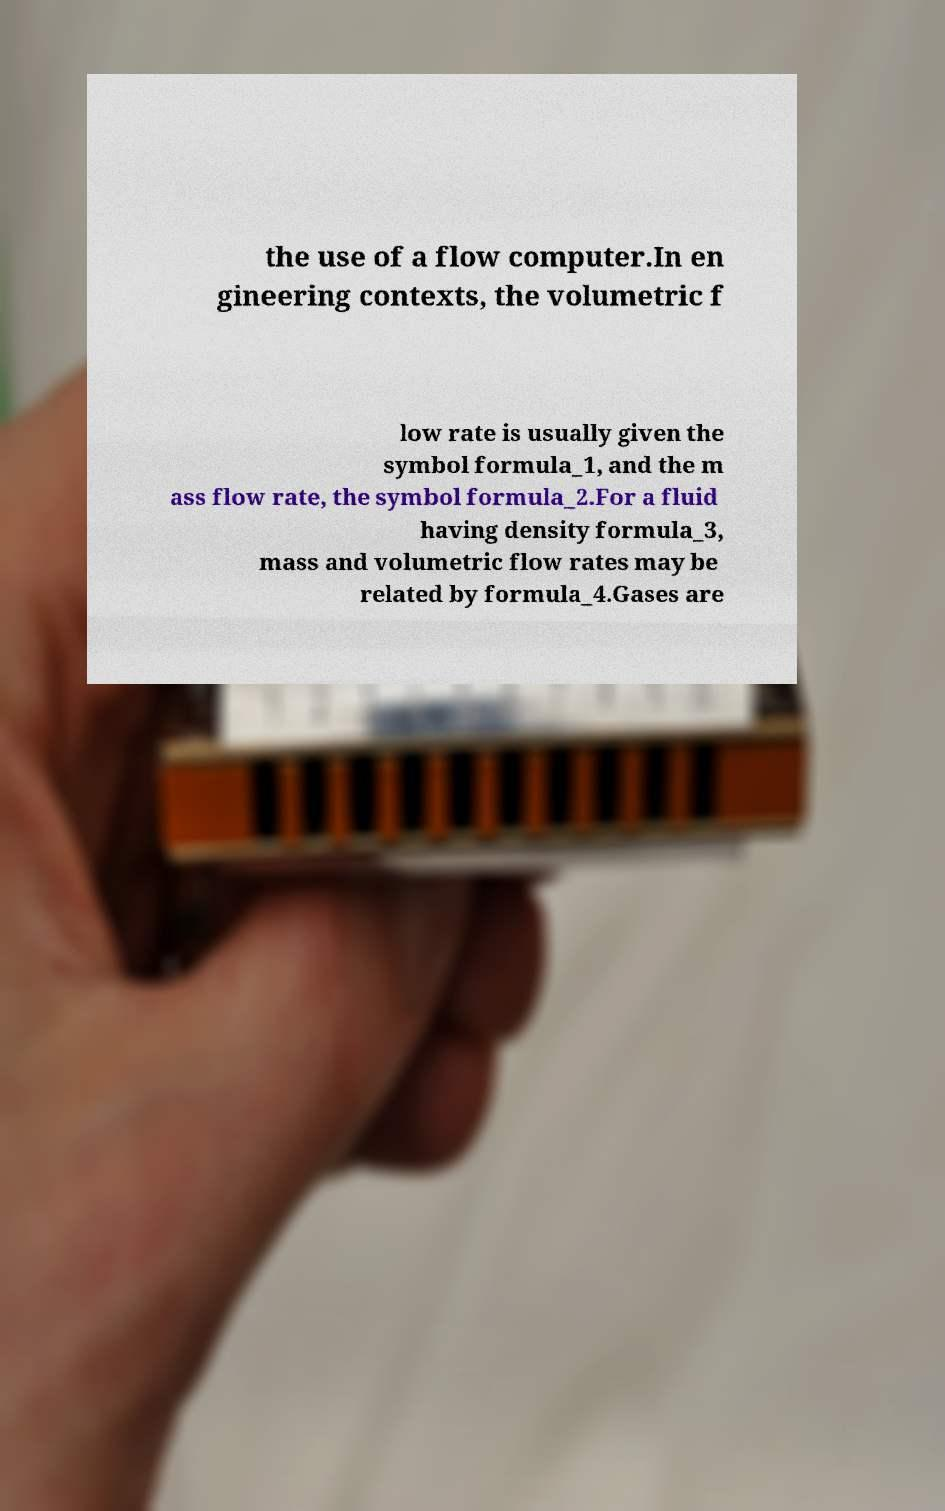Could you assist in decoding the text presented in this image and type it out clearly? the use of a flow computer.In en gineering contexts, the volumetric f low rate is usually given the symbol formula_1, and the m ass flow rate, the symbol formula_2.For a fluid having density formula_3, mass and volumetric flow rates may be related by formula_4.Gases are 